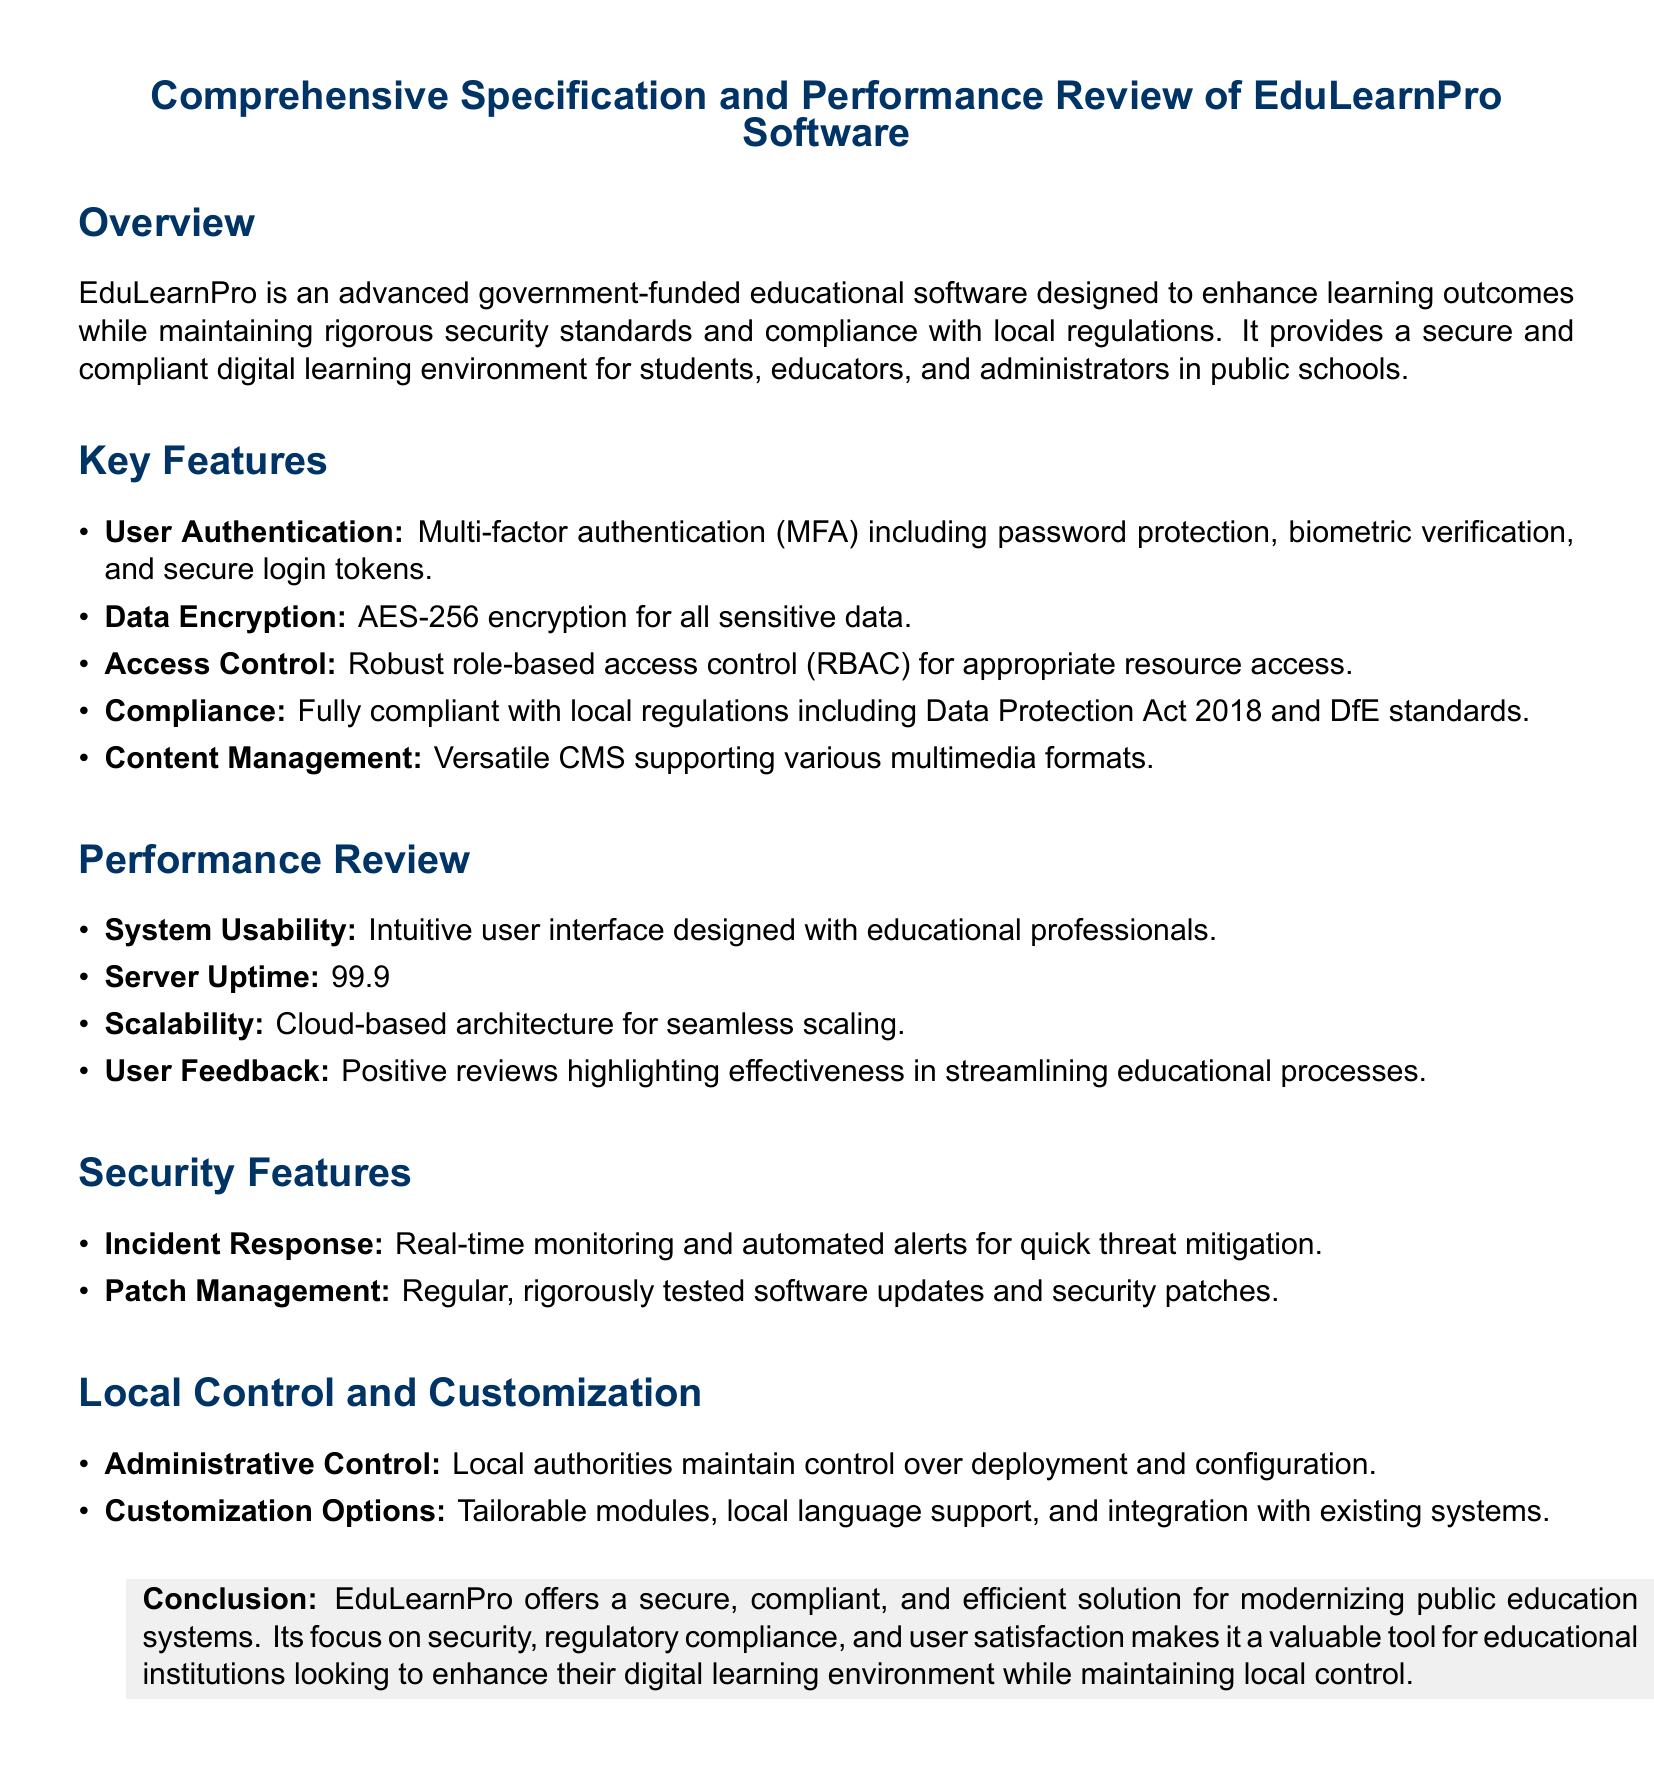what is the name of the software? The name of the software is mentioned at the beginning of the document.
Answer: EduLearnPro what percentage of server uptime is guaranteed? The document specifically states the uptime percentage guaranteed by the software.
Answer: 99.9% what type of authentication does the software use? The key features section mentions the methods used for user authentication in the software.
Answer: Multi-factor authentication which compliance regulation does the software adhere to? The compliance section specifies the local regulation that the software complies with.
Answer: Data Protection Act 2018 what does RBAC stand for? The term RBAC is used in the access control feature and refers to a specific access management mechanism.
Answer: Role-based access control how often are security patches applied? The performance review section discusses the maintenance practices for the software, specifically around security updates.
Answer: Regular who maintains control over deployment and configuration? The local control and customization section highlights who has administrative control over the software.
Answer: Local authorities how is user feedback characterized? The performance review section summarises user impressions of the software.
Answer: Positive reviews 